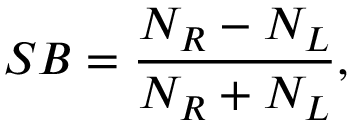Convert formula to latex. <formula><loc_0><loc_0><loc_500><loc_500>S B = \frac { N _ { R } - N _ { L } } { N _ { R } + N _ { L } } ,</formula> 